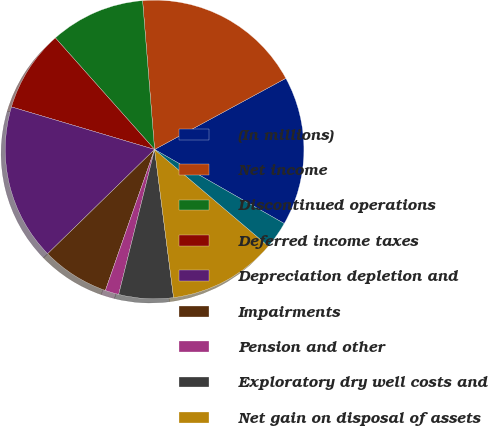Convert chart. <chart><loc_0><loc_0><loc_500><loc_500><pie_chart><fcel>(In millions)<fcel>Net income<fcel>Discontinued operations<fcel>Deferred income taxes<fcel>Depreciation depletion and<fcel>Impairments<fcel>Pension and other<fcel>Exploratory dry well costs and<fcel>Net gain on disposal of assets<fcel>Equity method investments net<nl><fcel>16.17%<fcel>18.37%<fcel>10.29%<fcel>8.83%<fcel>16.9%<fcel>7.36%<fcel>1.48%<fcel>5.89%<fcel>11.76%<fcel>2.95%<nl></chart> 